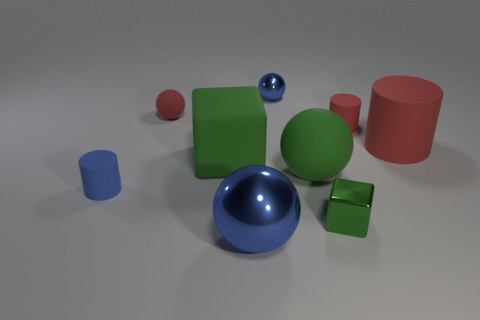Add 1 large blue objects. How many objects exist? 10 Subtract all cylinders. How many objects are left? 6 Subtract all big green spheres. Subtract all big red cylinders. How many objects are left? 7 Add 7 tiny green objects. How many tiny green objects are left? 8 Add 1 spheres. How many spheres exist? 5 Subtract 0 yellow spheres. How many objects are left? 9 